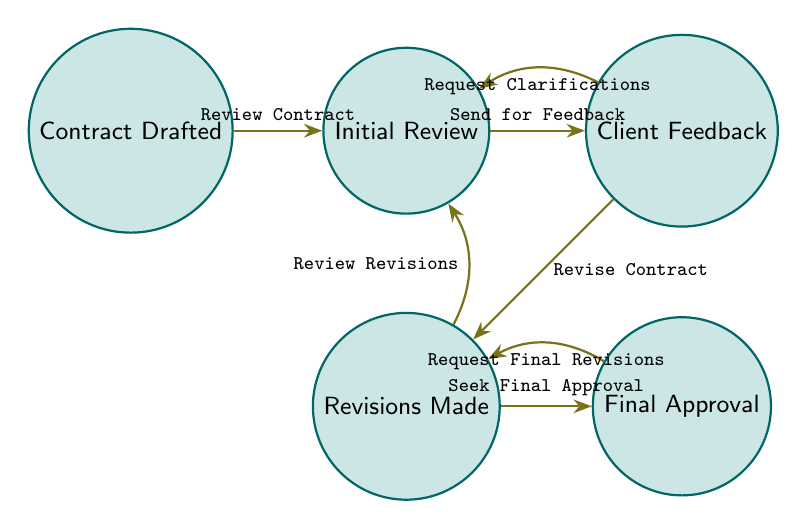What is the starting node in the process? The starting node is "Contract Drafted." This is where the process begins, and it is the first node visually represented in the diagram.
Answer: Contract Drafted How many nodes are present in the diagram? To find the number of nodes, you can count each unique state in the diagram. There are five distinct nodes: "Contract Drafted," "Initial Review," "Client Feedback," "Revisions Made," and "Final Approval."
Answer: 5 What action leads from "Initial Review" to "Client Feedback"? The action that connects these two nodes is "Send for Feedback." This is indicated as the directed edge from the "Initial Review" node to the "Client Feedback" node.
Answer: Send for Feedback What is the final node in the contract review process? The final node is "Final Approval." This is the endpoint of the process where the contract gets approved after all necessary revisions have been made.
Answer: Final Approval How many loopback edges are present in the diagram? Loopback edges are directed connections that return to a previous node without progressing the process. In this diagram, there are three loopback edges: from "Client Feedback" to "Initial Review," from "Revisions Made" to "Initial Review," and from "Final Approval" to "Revisions Made."
Answer: 3 What happens after "Client Feedback" if revisions are required? If revisions are required after "Client Feedback," the next action is "Revise Contract," which transitions the process from "Client Feedback" to "Revisions Made."
Answer: Revise Contract What is the relationship between "Revisions Made" and "Final Approval"? The relationship is defined by the action "Seek Final Approval," which moves the process from "Revisions Made" to "Final Approval." This indicates the step where approval is sought after revisions are completed.
Answer: Seek Final Approval What does "Request Clarifications" indicate in the process? "Request Clarifications" indicates a need for additional information or details after "Client Feedback," causing a loopback to the "Initial Review" before proceeding. This suggests that further clarification is necessary to continue the review process.
Answer: Request Clarifications What action occurs if "Final Approval" results in the need for changes? If "Final Approval" results in the need for changes, the action reflects "Request Final Revisions," leading back to "Revisions Made." This indicates the cycle of refining the contract until it meets the client's expectations.
Answer: Request Final Revisions 